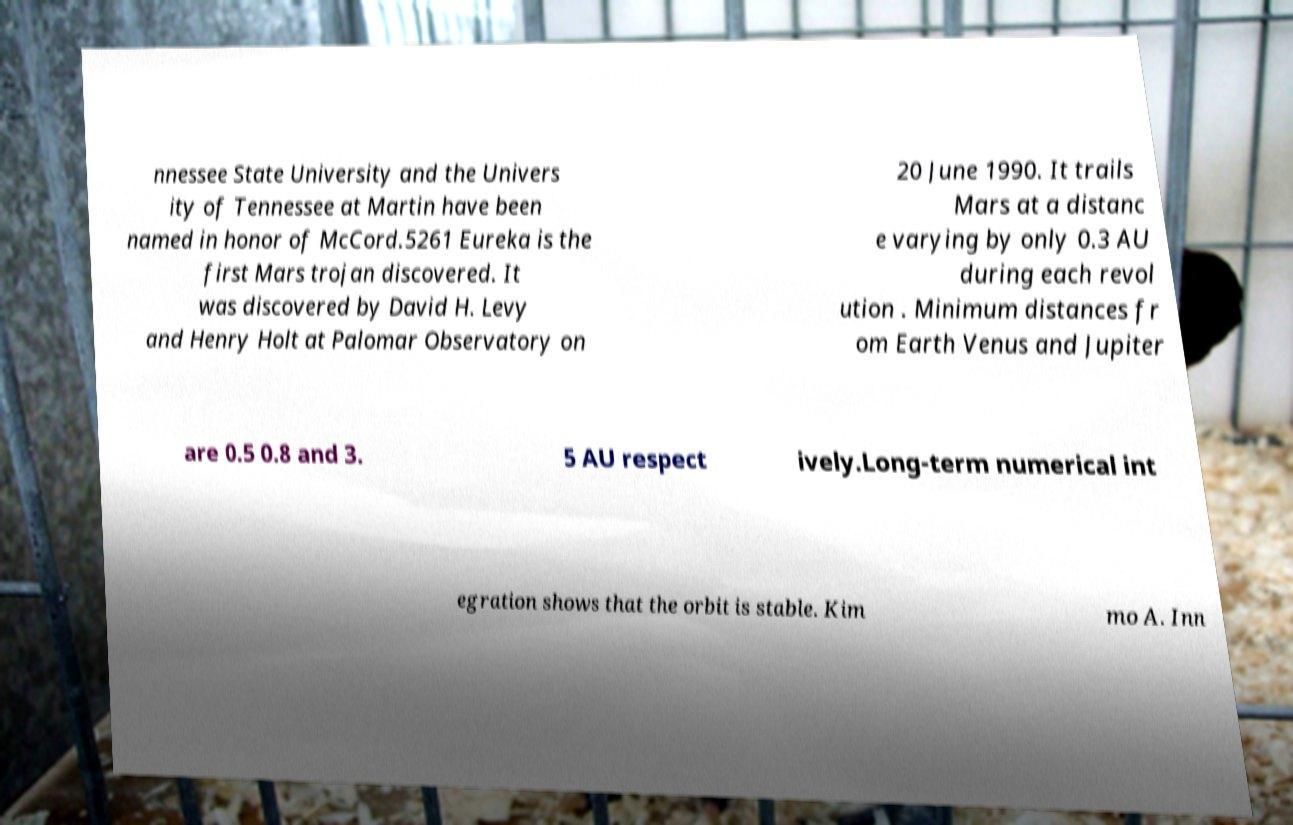Please read and relay the text visible in this image. What does it say? nnessee State University and the Univers ity of Tennessee at Martin have been named in honor of McCord.5261 Eureka is the first Mars trojan discovered. It was discovered by David H. Levy and Henry Holt at Palomar Observatory on 20 June 1990. It trails Mars at a distanc e varying by only 0.3 AU during each revol ution . Minimum distances fr om Earth Venus and Jupiter are 0.5 0.8 and 3. 5 AU respect ively.Long-term numerical int egration shows that the orbit is stable. Kim mo A. Inn 